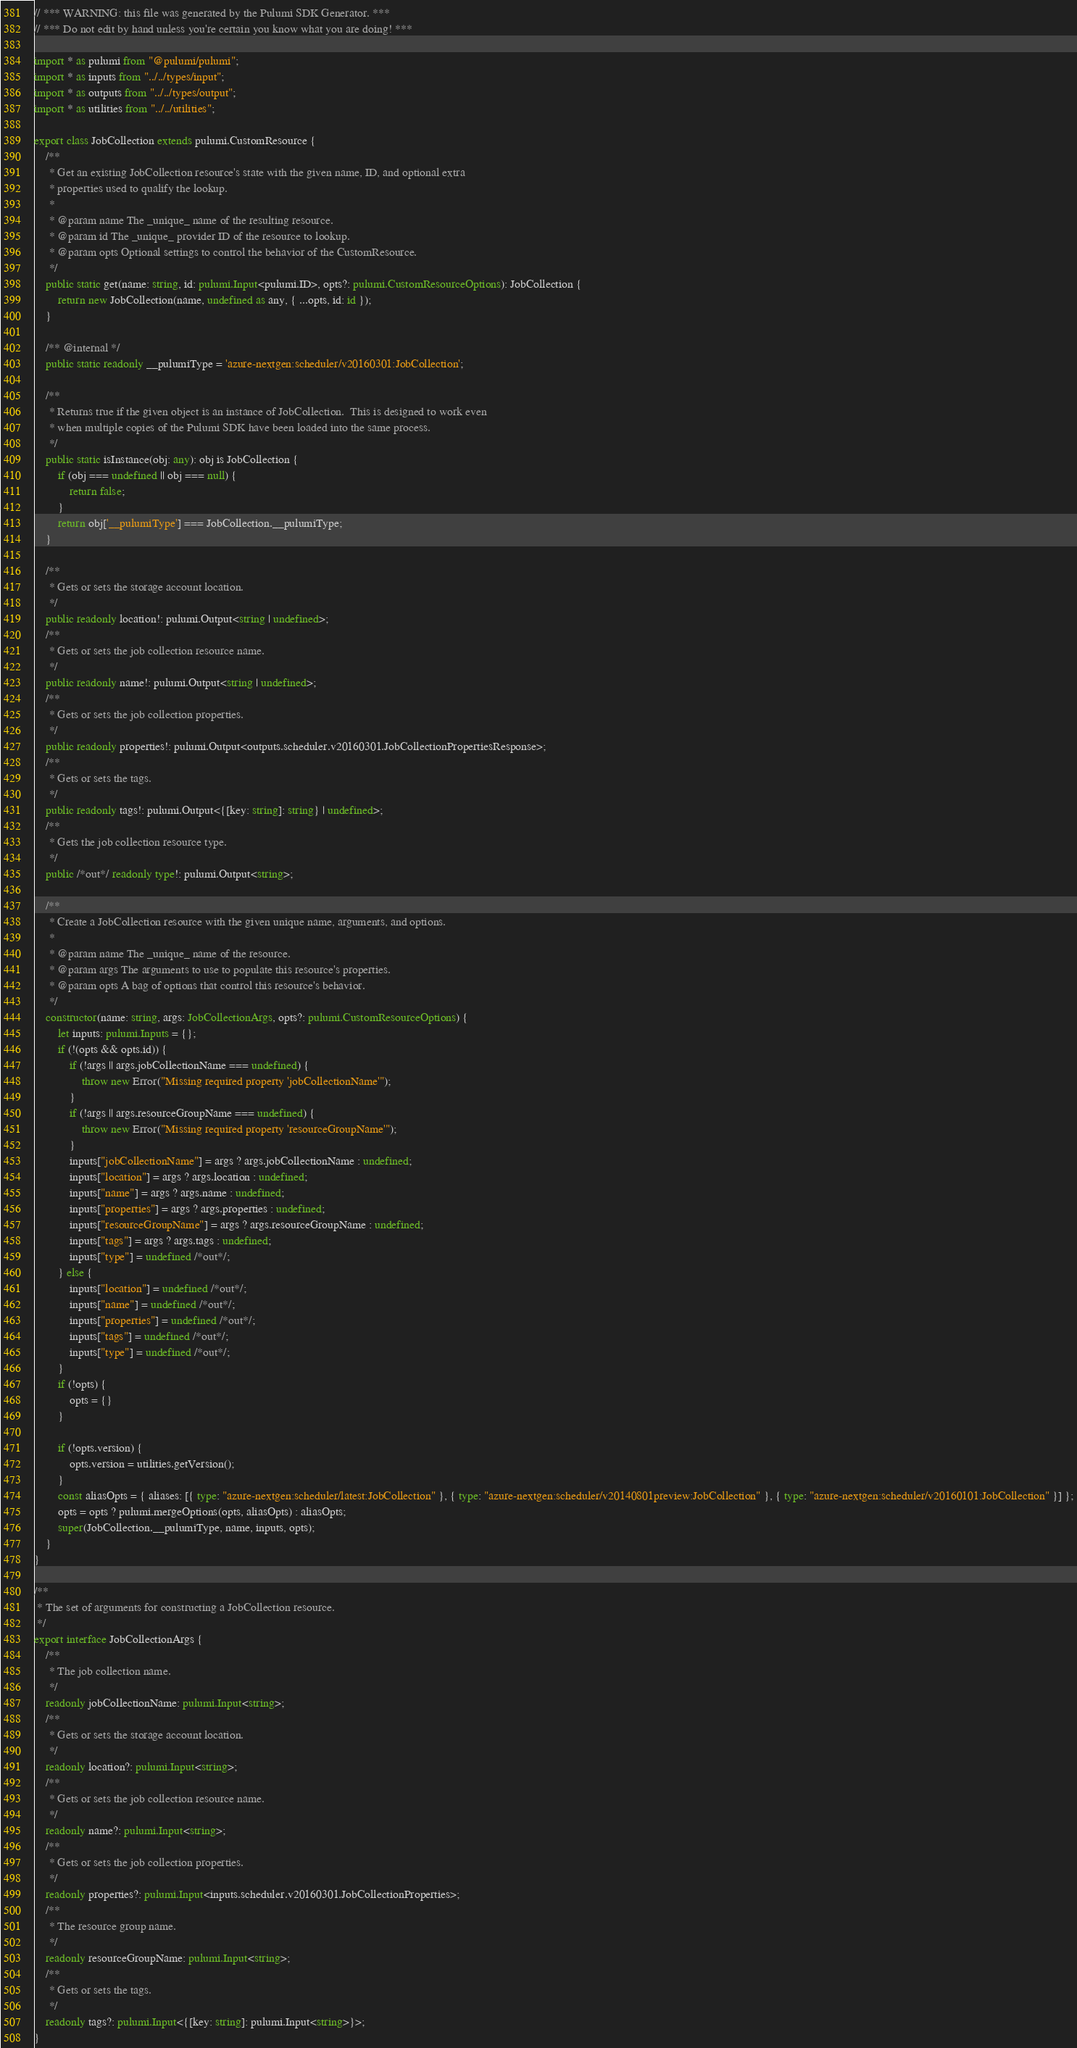<code> <loc_0><loc_0><loc_500><loc_500><_TypeScript_>// *** WARNING: this file was generated by the Pulumi SDK Generator. ***
// *** Do not edit by hand unless you're certain you know what you are doing! ***

import * as pulumi from "@pulumi/pulumi";
import * as inputs from "../../types/input";
import * as outputs from "../../types/output";
import * as utilities from "../../utilities";

export class JobCollection extends pulumi.CustomResource {
    /**
     * Get an existing JobCollection resource's state with the given name, ID, and optional extra
     * properties used to qualify the lookup.
     *
     * @param name The _unique_ name of the resulting resource.
     * @param id The _unique_ provider ID of the resource to lookup.
     * @param opts Optional settings to control the behavior of the CustomResource.
     */
    public static get(name: string, id: pulumi.Input<pulumi.ID>, opts?: pulumi.CustomResourceOptions): JobCollection {
        return new JobCollection(name, undefined as any, { ...opts, id: id });
    }

    /** @internal */
    public static readonly __pulumiType = 'azure-nextgen:scheduler/v20160301:JobCollection';

    /**
     * Returns true if the given object is an instance of JobCollection.  This is designed to work even
     * when multiple copies of the Pulumi SDK have been loaded into the same process.
     */
    public static isInstance(obj: any): obj is JobCollection {
        if (obj === undefined || obj === null) {
            return false;
        }
        return obj['__pulumiType'] === JobCollection.__pulumiType;
    }

    /**
     * Gets or sets the storage account location.
     */
    public readonly location!: pulumi.Output<string | undefined>;
    /**
     * Gets or sets the job collection resource name.
     */
    public readonly name!: pulumi.Output<string | undefined>;
    /**
     * Gets or sets the job collection properties.
     */
    public readonly properties!: pulumi.Output<outputs.scheduler.v20160301.JobCollectionPropertiesResponse>;
    /**
     * Gets or sets the tags.
     */
    public readonly tags!: pulumi.Output<{[key: string]: string} | undefined>;
    /**
     * Gets the job collection resource type.
     */
    public /*out*/ readonly type!: pulumi.Output<string>;

    /**
     * Create a JobCollection resource with the given unique name, arguments, and options.
     *
     * @param name The _unique_ name of the resource.
     * @param args The arguments to use to populate this resource's properties.
     * @param opts A bag of options that control this resource's behavior.
     */
    constructor(name: string, args: JobCollectionArgs, opts?: pulumi.CustomResourceOptions) {
        let inputs: pulumi.Inputs = {};
        if (!(opts && opts.id)) {
            if (!args || args.jobCollectionName === undefined) {
                throw new Error("Missing required property 'jobCollectionName'");
            }
            if (!args || args.resourceGroupName === undefined) {
                throw new Error("Missing required property 'resourceGroupName'");
            }
            inputs["jobCollectionName"] = args ? args.jobCollectionName : undefined;
            inputs["location"] = args ? args.location : undefined;
            inputs["name"] = args ? args.name : undefined;
            inputs["properties"] = args ? args.properties : undefined;
            inputs["resourceGroupName"] = args ? args.resourceGroupName : undefined;
            inputs["tags"] = args ? args.tags : undefined;
            inputs["type"] = undefined /*out*/;
        } else {
            inputs["location"] = undefined /*out*/;
            inputs["name"] = undefined /*out*/;
            inputs["properties"] = undefined /*out*/;
            inputs["tags"] = undefined /*out*/;
            inputs["type"] = undefined /*out*/;
        }
        if (!opts) {
            opts = {}
        }

        if (!opts.version) {
            opts.version = utilities.getVersion();
        }
        const aliasOpts = { aliases: [{ type: "azure-nextgen:scheduler/latest:JobCollection" }, { type: "azure-nextgen:scheduler/v20140801preview:JobCollection" }, { type: "azure-nextgen:scheduler/v20160101:JobCollection" }] };
        opts = opts ? pulumi.mergeOptions(opts, aliasOpts) : aliasOpts;
        super(JobCollection.__pulumiType, name, inputs, opts);
    }
}

/**
 * The set of arguments for constructing a JobCollection resource.
 */
export interface JobCollectionArgs {
    /**
     * The job collection name.
     */
    readonly jobCollectionName: pulumi.Input<string>;
    /**
     * Gets or sets the storage account location.
     */
    readonly location?: pulumi.Input<string>;
    /**
     * Gets or sets the job collection resource name.
     */
    readonly name?: pulumi.Input<string>;
    /**
     * Gets or sets the job collection properties.
     */
    readonly properties?: pulumi.Input<inputs.scheduler.v20160301.JobCollectionProperties>;
    /**
     * The resource group name.
     */
    readonly resourceGroupName: pulumi.Input<string>;
    /**
     * Gets or sets the tags.
     */
    readonly tags?: pulumi.Input<{[key: string]: pulumi.Input<string>}>;
}
</code> 